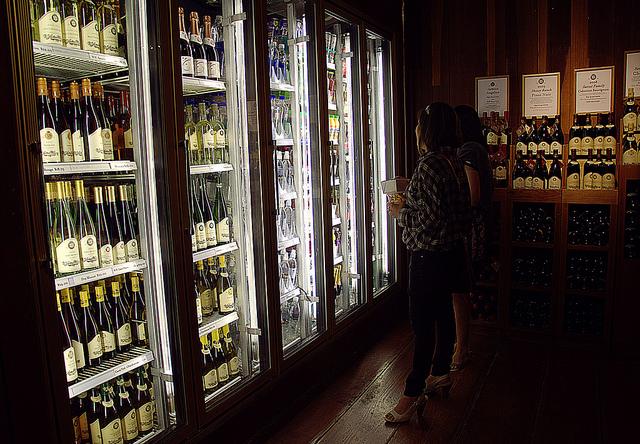How many bottles of wine are there?
Give a very brief answer. Lot. Any men in the picture?
Quick response, please. No. How many wines are merlo?
Short answer required. 20. What color are the shoes being worn?
Concise answer only. White. Is this at a grocery store?
Be succinct. No. What are the cabinets made of?
Concise answer only. Glass. What do people do in here?
Write a very short answer. Shop. What are on the shelves?
Concise answer only. Wine. How many bottles are in front of the man?
Write a very short answer. Lot. 